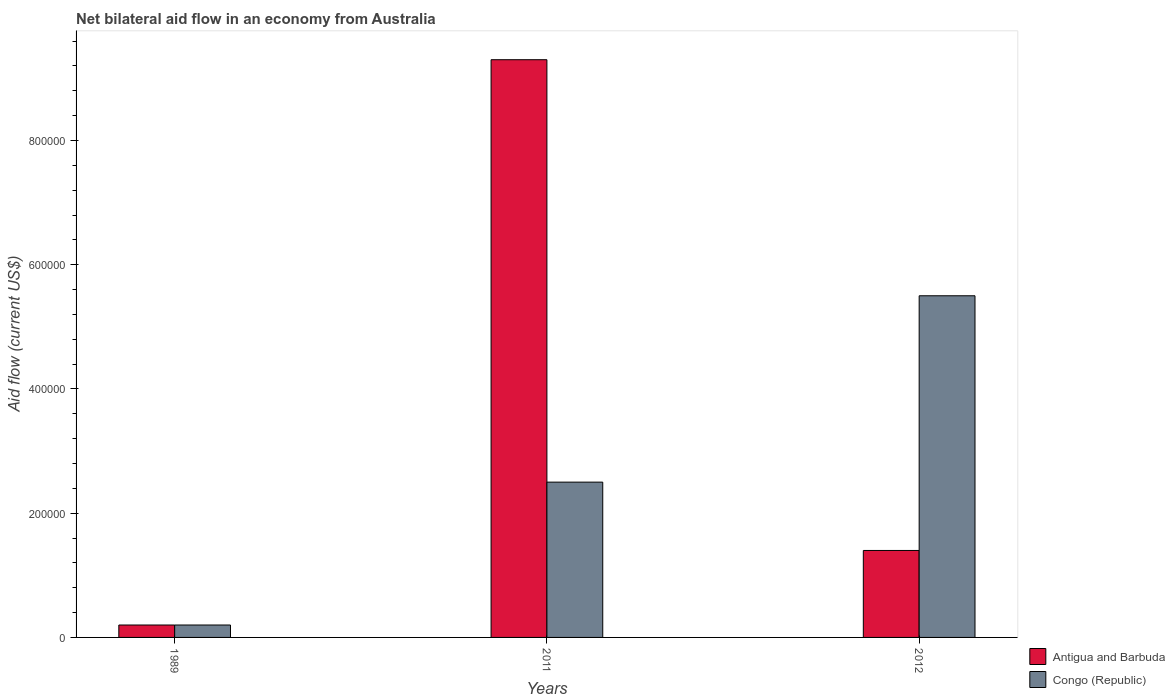How many bars are there on the 2nd tick from the right?
Offer a very short reply. 2. What is the label of the 2nd group of bars from the left?
Give a very brief answer. 2011. In how many cases, is the number of bars for a given year not equal to the number of legend labels?
Your answer should be compact. 0. Across all years, what is the maximum net bilateral aid flow in Antigua and Barbuda?
Provide a succinct answer. 9.30e+05. Across all years, what is the minimum net bilateral aid flow in Congo (Republic)?
Provide a succinct answer. 2.00e+04. In which year was the net bilateral aid flow in Antigua and Barbuda maximum?
Offer a very short reply. 2011. In which year was the net bilateral aid flow in Congo (Republic) minimum?
Ensure brevity in your answer.  1989. What is the total net bilateral aid flow in Congo (Republic) in the graph?
Make the answer very short. 8.20e+05. What is the average net bilateral aid flow in Antigua and Barbuda per year?
Your answer should be very brief. 3.63e+05. In the year 2012, what is the difference between the net bilateral aid flow in Congo (Republic) and net bilateral aid flow in Antigua and Barbuda?
Keep it short and to the point. 4.10e+05. What is the difference between the highest and the second highest net bilateral aid flow in Antigua and Barbuda?
Provide a succinct answer. 7.90e+05. What is the difference between the highest and the lowest net bilateral aid flow in Congo (Republic)?
Ensure brevity in your answer.  5.30e+05. In how many years, is the net bilateral aid flow in Antigua and Barbuda greater than the average net bilateral aid flow in Antigua and Barbuda taken over all years?
Offer a terse response. 1. What does the 1st bar from the left in 2011 represents?
Keep it short and to the point. Antigua and Barbuda. What does the 2nd bar from the right in 1989 represents?
Your answer should be very brief. Antigua and Barbuda. How many years are there in the graph?
Keep it short and to the point. 3. What is the difference between two consecutive major ticks on the Y-axis?
Your answer should be compact. 2.00e+05. Does the graph contain grids?
Make the answer very short. No. How many legend labels are there?
Offer a terse response. 2. What is the title of the graph?
Provide a short and direct response. Net bilateral aid flow in an economy from Australia. Does "Iraq" appear as one of the legend labels in the graph?
Offer a terse response. No. What is the label or title of the Y-axis?
Provide a succinct answer. Aid flow (current US$). What is the Aid flow (current US$) of Antigua and Barbuda in 2011?
Your answer should be very brief. 9.30e+05. What is the Aid flow (current US$) in Antigua and Barbuda in 2012?
Give a very brief answer. 1.40e+05. What is the Aid flow (current US$) in Congo (Republic) in 2012?
Your response must be concise. 5.50e+05. Across all years, what is the maximum Aid flow (current US$) in Antigua and Barbuda?
Make the answer very short. 9.30e+05. Across all years, what is the minimum Aid flow (current US$) in Antigua and Barbuda?
Provide a short and direct response. 2.00e+04. Across all years, what is the minimum Aid flow (current US$) in Congo (Republic)?
Offer a terse response. 2.00e+04. What is the total Aid flow (current US$) in Antigua and Barbuda in the graph?
Ensure brevity in your answer.  1.09e+06. What is the total Aid flow (current US$) in Congo (Republic) in the graph?
Provide a succinct answer. 8.20e+05. What is the difference between the Aid flow (current US$) in Antigua and Barbuda in 1989 and that in 2011?
Make the answer very short. -9.10e+05. What is the difference between the Aid flow (current US$) in Congo (Republic) in 1989 and that in 2011?
Keep it short and to the point. -2.30e+05. What is the difference between the Aid flow (current US$) in Antigua and Barbuda in 1989 and that in 2012?
Make the answer very short. -1.20e+05. What is the difference between the Aid flow (current US$) of Congo (Republic) in 1989 and that in 2012?
Your response must be concise. -5.30e+05. What is the difference between the Aid flow (current US$) in Antigua and Barbuda in 2011 and that in 2012?
Your response must be concise. 7.90e+05. What is the difference between the Aid flow (current US$) in Antigua and Barbuda in 1989 and the Aid flow (current US$) in Congo (Republic) in 2011?
Keep it short and to the point. -2.30e+05. What is the difference between the Aid flow (current US$) of Antigua and Barbuda in 1989 and the Aid flow (current US$) of Congo (Republic) in 2012?
Your answer should be compact. -5.30e+05. What is the average Aid flow (current US$) in Antigua and Barbuda per year?
Your answer should be very brief. 3.63e+05. What is the average Aid flow (current US$) in Congo (Republic) per year?
Your answer should be very brief. 2.73e+05. In the year 2011, what is the difference between the Aid flow (current US$) in Antigua and Barbuda and Aid flow (current US$) in Congo (Republic)?
Give a very brief answer. 6.80e+05. In the year 2012, what is the difference between the Aid flow (current US$) of Antigua and Barbuda and Aid flow (current US$) of Congo (Republic)?
Ensure brevity in your answer.  -4.10e+05. What is the ratio of the Aid flow (current US$) of Antigua and Barbuda in 1989 to that in 2011?
Offer a terse response. 0.02. What is the ratio of the Aid flow (current US$) of Antigua and Barbuda in 1989 to that in 2012?
Your answer should be compact. 0.14. What is the ratio of the Aid flow (current US$) in Congo (Republic) in 1989 to that in 2012?
Offer a very short reply. 0.04. What is the ratio of the Aid flow (current US$) in Antigua and Barbuda in 2011 to that in 2012?
Ensure brevity in your answer.  6.64. What is the ratio of the Aid flow (current US$) of Congo (Republic) in 2011 to that in 2012?
Keep it short and to the point. 0.45. What is the difference between the highest and the second highest Aid flow (current US$) of Antigua and Barbuda?
Make the answer very short. 7.90e+05. What is the difference between the highest and the lowest Aid flow (current US$) of Antigua and Barbuda?
Provide a succinct answer. 9.10e+05. What is the difference between the highest and the lowest Aid flow (current US$) of Congo (Republic)?
Make the answer very short. 5.30e+05. 